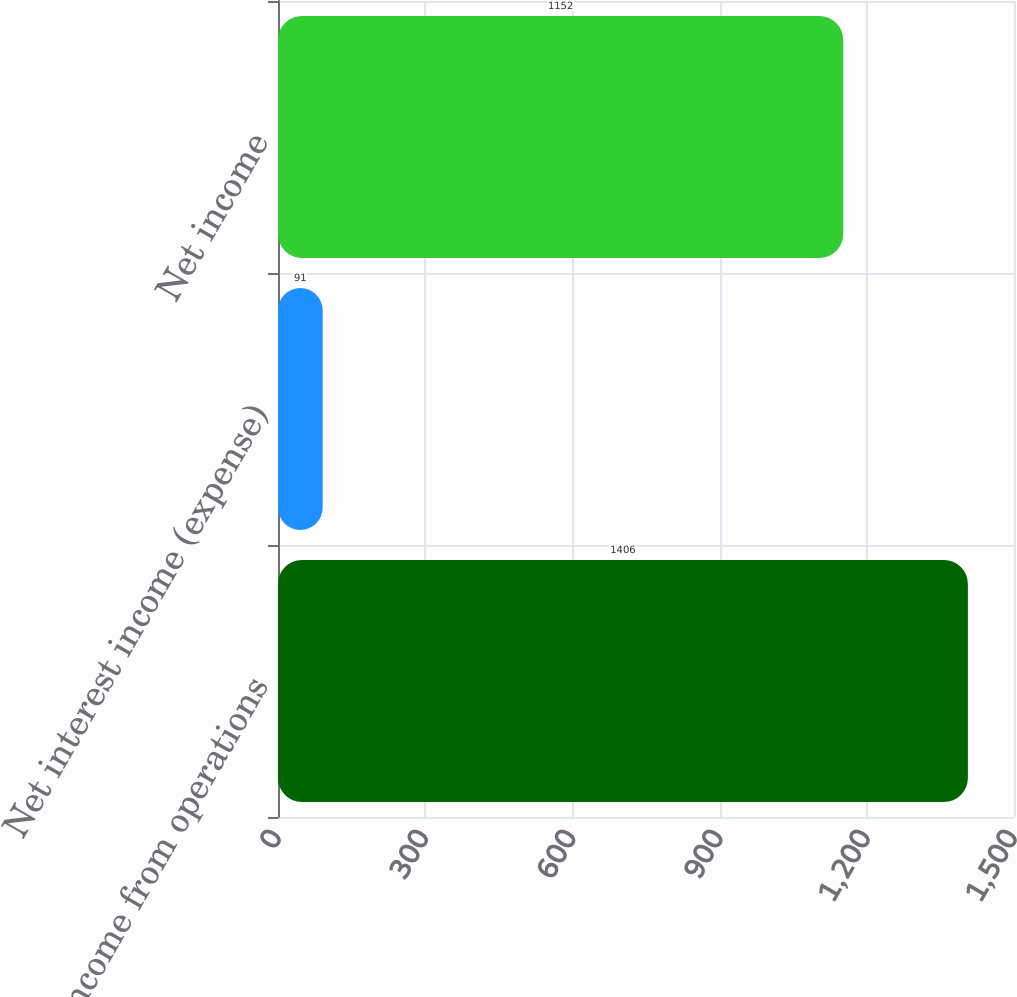Convert chart. <chart><loc_0><loc_0><loc_500><loc_500><bar_chart><fcel>Income from operations<fcel>Net interest income (expense)<fcel>Net income<nl><fcel>1406<fcel>91<fcel>1152<nl></chart> 